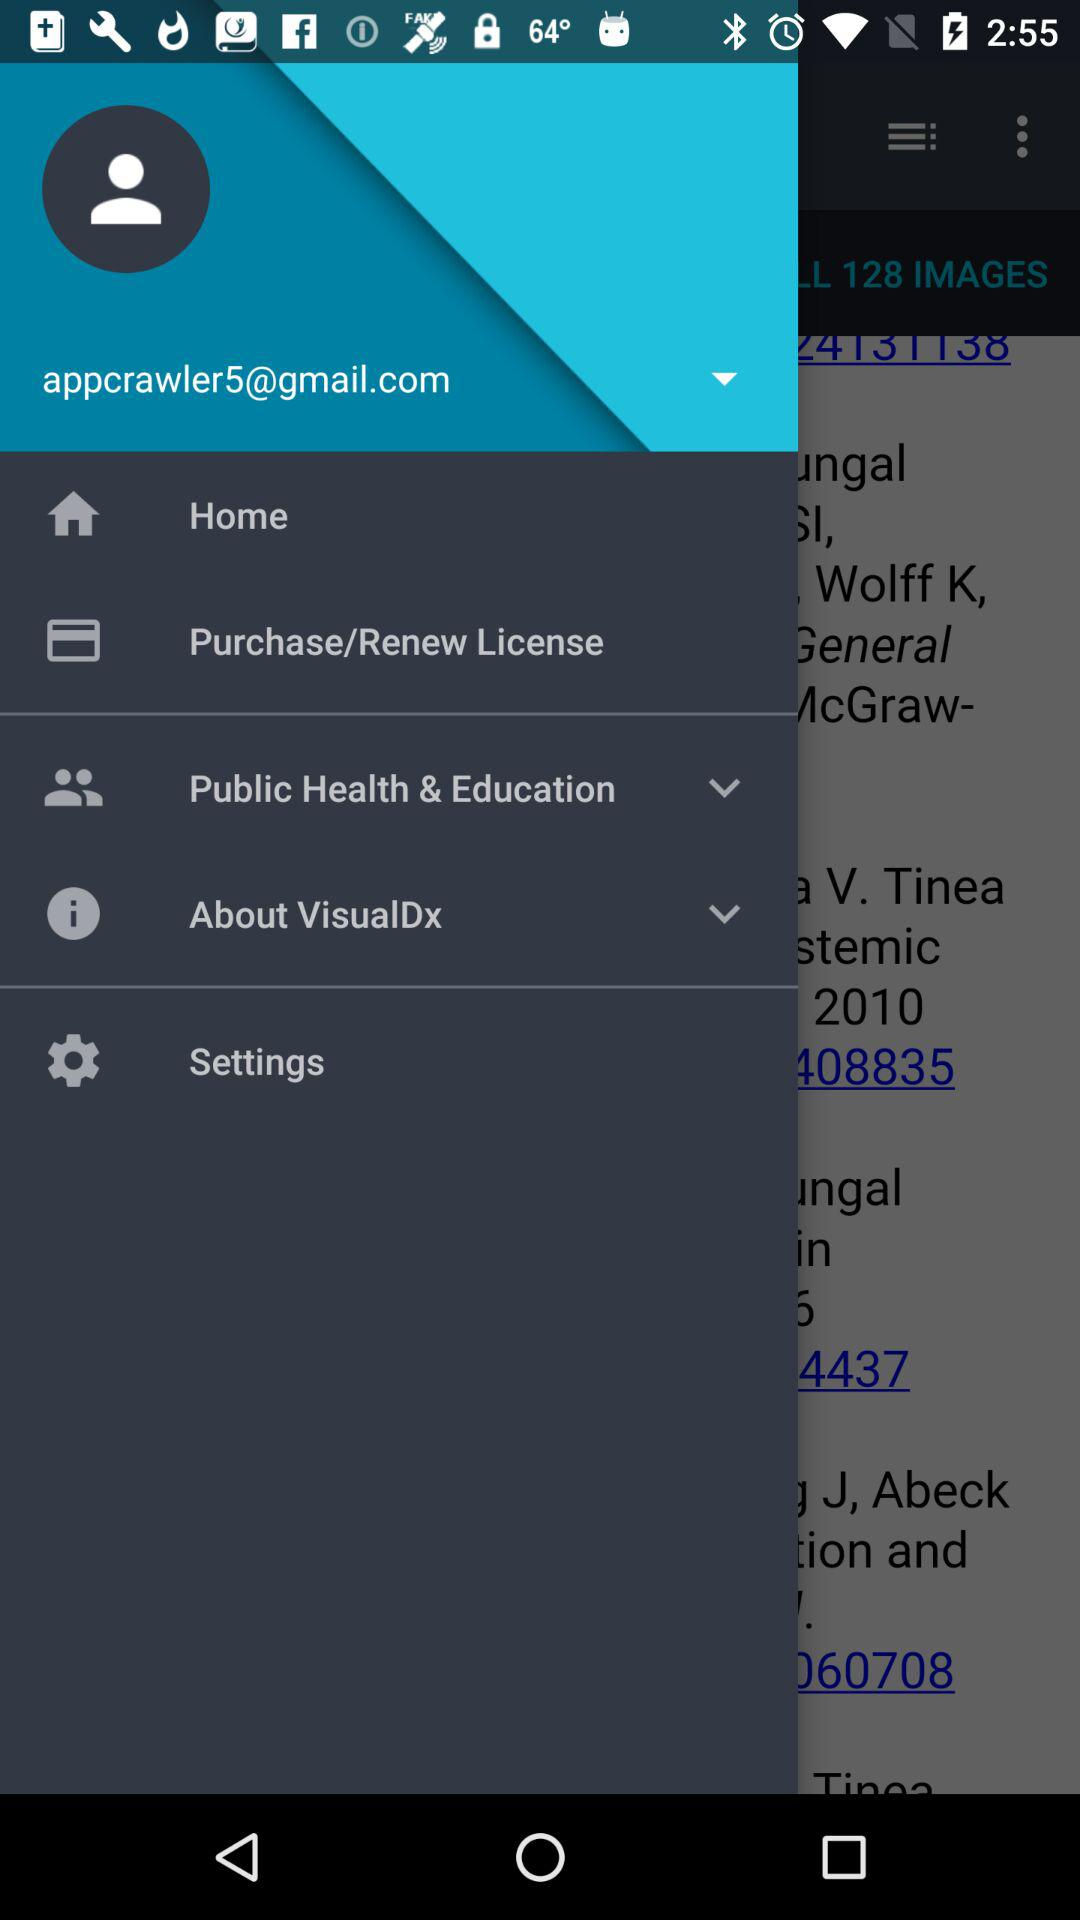What is the email address? The email address is appcrawler5@gmail.com. 